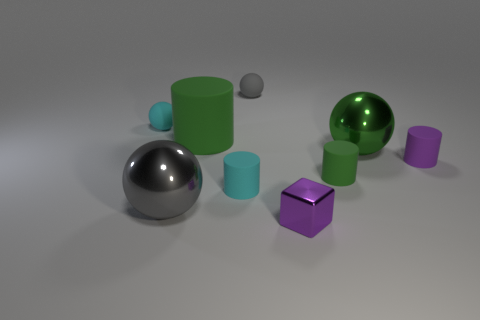What size is the purple matte thing that is the same shape as the big green matte thing? The purple object, which shares its cube shape with the larger green object, is comparatively small in size. 